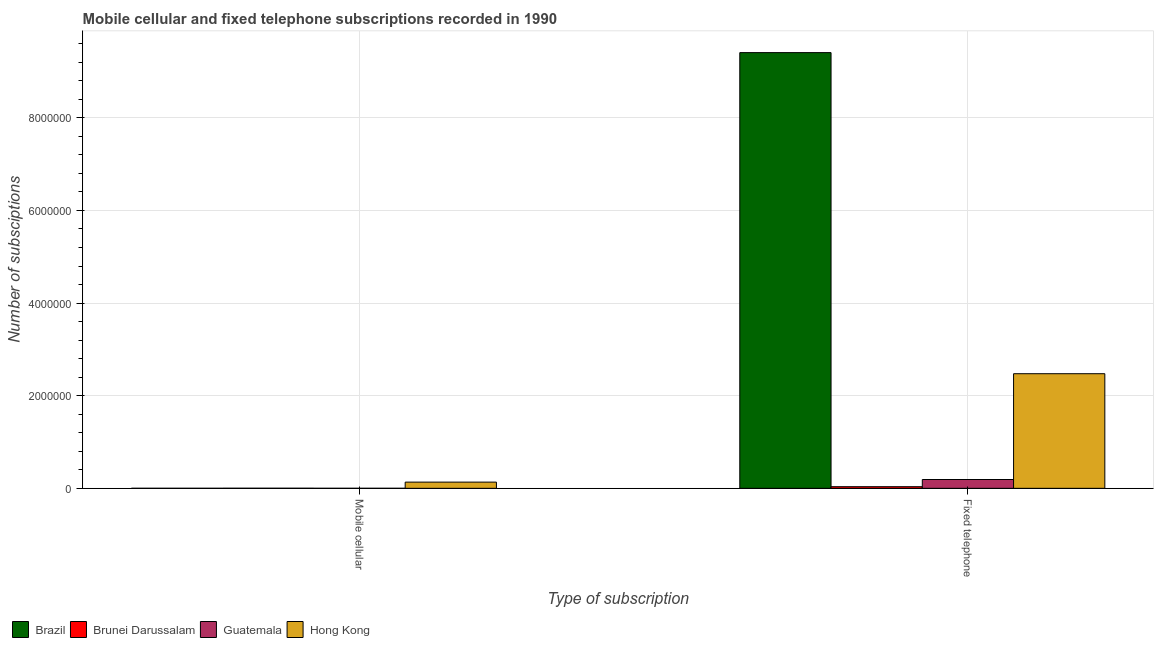How many different coloured bars are there?
Offer a terse response. 4. Are the number of bars per tick equal to the number of legend labels?
Your answer should be very brief. Yes. Are the number of bars on each tick of the X-axis equal?
Provide a succinct answer. Yes. How many bars are there on the 2nd tick from the right?
Your answer should be very brief. 4. What is the label of the 2nd group of bars from the left?
Provide a short and direct response. Fixed telephone. What is the number of fixed telephone subscriptions in Hong Kong?
Offer a very short reply. 2.47e+06. Across all countries, what is the maximum number of fixed telephone subscriptions?
Make the answer very short. 9.41e+06. Across all countries, what is the minimum number of fixed telephone subscriptions?
Offer a terse response. 3.50e+04. In which country was the number of mobile cellular subscriptions minimum?
Make the answer very short. Guatemala. What is the total number of fixed telephone subscriptions in the graph?
Your answer should be very brief. 1.21e+07. What is the difference between the number of mobile cellular subscriptions in Brunei Darussalam and that in Hong Kong?
Offer a terse response. -1.32e+05. What is the difference between the number of mobile cellular subscriptions in Brazil and the number of fixed telephone subscriptions in Guatemala?
Make the answer very short. -1.90e+05. What is the average number of mobile cellular subscriptions per country?
Your answer should be compact. 3.42e+04. What is the difference between the number of mobile cellular subscriptions and number of fixed telephone subscriptions in Guatemala?
Your answer should be very brief. -1.90e+05. In how many countries, is the number of mobile cellular subscriptions greater than 2800000 ?
Keep it short and to the point. 0. What is the ratio of the number of mobile cellular subscriptions in Hong Kong to that in Brazil?
Give a very brief answer. 200.77. What does the 2nd bar from the left in Mobile cellular represents?
Ensure brevity in your answer.  Brunei Darussalam. What does the 4th bar from the right in Mobile cellular represents?
Offer a terse response. Brazil. How many bars are there?
Provide a short and direct response. 8. Are all the bars in the graph horizontal?
Your response must be concise. No. What is the difference between two consecutive major ticks on the Y-axis?
Offer a terse response. 2.00e+06. Are the values on the major ticks of Y-axis written in scientific E-notation?
Offer a terse response. No. Does the graph contain any zero values?
Provide a short and direct response. No. Does the graph contain grids?
Ensure brevity in your answer.  Yes. How are the legend labels stacked?
Provide a short and direct response. Horizontal. What is the title of the graph?
Keep it short and to the point. Mobile cellular and fixed telephone subscriptions recorded in 1990. Does "Malawi" appear as one of the legend labels in the graph?
Provide a succinct answer. No. What is the label or title of the X-axis?
Give a very brief answer. Type of subscription. What is the label or title of the Y-axis?
Make the answer very short. Number of subsciptions. What is the Number of subsciptions of Brazil in Mobile cellular?
Provide a succinct answer. 667. What is the Number of subsciptions in Brunei Darussalam in Mobile cellular?
Your response must be concise. 1772. What is the Number of subsciptions in Guatemala in Mobile cellular?
Make the answer very short. 293. What is the Number of subsciptions of Hong Kong in Mobile cellular?
Your response must be concise. 1.34e+05. What is the Number of subsciptions in Brazil in Fixed telephone?
Your response must be concise. 9.41e+06. What is the Number of subsciptions in Brunei Darussalam in Fixed telephone?
Offer a terse response. 3.50e+04. What is the Number of subsciptions of Guatemala in Fixed telephone?
Offer a terse response. 1.90e+05. What is the Number of subsciptions of Hong Kong in Fixed telephone?
Your answer should be very brief. 2.47e+06. Across all Type of subscription, what is the maximum Number of subsciptions in Brazil?
Provide a short and direct response. 9.41e+06. Across all Type of subscription, what is the maximum Number of subsciptions of Brunei Darussalam?
Your answer should be compact. 3.50e+04. Across all Type of subscription, what is the maximum Number of subsciptions of Guatemala?
Your answer should be very brief. 1.90e+05. Across all Type of subscription, what is the maximum Number of subsciptions of Hong Kong?
Your response must be concise. 2.47e+06. Across all Type of subscription, what is the minimum Number of subsciptions in Brazil?
Keep it short and to the point. 667. Across all Type of subscription, what is the minimum Number of subsciptions of Brunei Darussalam?
Your answer should be very brief. 1772. Across all Type of subscription, what is the minimum Number of subsciptions in Guatemala?
Provide a short and direct response. 293. Across all Type of subscription, what is the minimum Number of subsciptions of Hong Kong?
Your answer should be compact. 1.34e+05. What is the total Number of subsciptions in Brazil in the graph?
Your response must be concise. 9.41e+06. What is the total Number of subsciptions in Brunei Darussalam in the graph?
Ensure brevity in your answer.  3.68e+04. What is the total Number of subsciptions of Guatemala in the graph?
Your answer should be very brief. 1.91e+05. What is the total Number of subsciptions in Hong Kong in the graph?
Provide a short and direct response. 2.61e+06. What is the difference between the Number of subsciptions in Brazil in Mobile cellular and that in Fixed telephone?
Provide a short and direct response. -9.41e+06. What is the difference between the Number of subsciptions of Brunei Darussalam in Mobile cellular and that in Fixed telephone?
Offer a terse response. -3.32e+04. What is the difference between the Number of subsciptions in Guatemala in Mobile cellular and that in Fixed telephone?
Provide a short and direct response. -1.90e+05. What is the difference between the Number of subsciptions in Hong Kong in Mobile cellular and that in Fixed telephone?
Give a very brief answer. -2.34e+06. What is the difference between the Number of subsciptions of Brazil in Mobile cellular and the Number of subsciptions of Brunei Darussalam in Fixed telephone?
Your answer should be compact. -3.43e+04. What is the difference between the Number of subsciptions in Brazil in Mobile cellular and the Number of subsciptions in Guatemala in Fixed telephone?
Ensure brevity in your answer.  -1.90e+05. What is the difference between the Number of subsciptions in Brazil in Mobile cellular and the Number of subsciptions in Hong Kong in Fixed telephone?
Provide a short and direct response. -2.47e+06. What is the difference between the Number of subsciptions of Brunei Darussalam in Mobile cellular and the Number of subsciptions of Guatemala in Fixed telephone?
Offer a terse response. -1.88e+05. What is the difference between the Number of subsciptions in Brunei Darussalam in Mobile cellular and the Number of subsciptions in Hong Kong in Fixed telephone?
Offer a very short reply. -2.47e+06. What is the difference between the Number of subsciptions in Guatemala in Mobile cellular and the Number of subsciptions in Hong Kong in Fixed telephone?
Keep it short and to the point. -2.47e+06. What is the average Number of subsciptions of Brazil per Type of subscription?
Give a very brief answer. 4.70e+06. What is the average Number of subsciptions in Brunei Darussalam per Type of subscription?
Give a very brief answer. 1.84e+04. What is the average Number of subsciptions in Guatemala per Type of subscription?
Offer a very short reply. 9.53e+04. What is the average Number of subsciptions of Hong Kong per Type of subscription?
Your response must be concise. 1.30e+06. What is the difference between the Number of subsciptions of Brazil and Number of subsciptions of Brunei Darussalam in Mobile cellular?
Give a very brief answer. -1105. What is the difference between the Number of subsciptions in Brazil and Number of subsciptions in Guatemala in Mobile cellular?
Offer a terse response. 374. What is the difference between the Number of subsciptions of Brazil and Number of subsciptions of Hong Kong in Mobile cellular?
Offer a terse response. -1.33e+05. What is the difference between the Number of subsciptions of Brunei Darussalam and Number of subsciptions of Guatemala in Mobile cellular?
Provide a succinct answer. 1479. What is the difference between the Number of subsciptions of Brunei Darussalam and Number of subsciptions of Hong Kong in Mobile cellular?
Your answer should be very brief. -1.32e+05. What is the difference between the Number of subsciptions in Guatemala and Number of subsciptions in Hong Kong in Mobile cellular?
Your answer should be compact. -1.34e+05. What is the difference between the Number of subsciptions in Brazil and Number of subsciptions in Brunei Darussalam in Fixed telephone?
Your answer should be very brief. 9.37e+06. What is the difference between the Number of subsciptions in Brazil and Number of subsciptions in Guatemala in Fixed telephone?
Your response must be concise. 9.22e+06. What is the difference between the Number of subsciptions in Brazil and Number of subsciptions in Hong Kong in Fixed telephone?
Provide a short and direct response. 6.93e+06. What is the difference between the Number of subsciptions of Brunei Darussalam and Number of subsciptions of Guatemala in Fixed telephone?
Your response must be concise. -1.55e+05. What is the difference between the Number of subsciptions of Brunei Darussalam and Number of subsciptions of Hong Kong in Fixed telephone?
Offer a very short reply. -2.44e+06. What is the difference between the Number of subsciptions in Guatemala and Number of subsciptions in Hong Kong in Fixed telephone?
Your answer should be compact. -2.28e+06. What is the ratio of the Number of subsciptions in Brunei Darussalam in Mobile cellular to that in Fixed telephone?
Your answer should be very brief. 0.05. What is the ratio of the Number of subsciptions in Guatemala in Mobile cellular to that in Fixed telephone?
Provide a short and direct response. 0. What is the ratio of the Number of subsciptions in Hong Kong in Mobile cellular to that in Fixed telephone?
Offer a terse response. 0.05. What is the difference between the highest and the second highest Number of subsciptions of Brazil?
Offer a terse response. 9.41e+06. What is the difference between the highest and the second highest Number of subsciptions of Brunei Darussalam?
Ensure brevity in your answer.  3.32e+04. What is the difference between the highest and the second highest Number of subsciptions of Guatemala?
Ensure brevity in your answer.  1.90e+05. What is the difference between the highest and the second highest Number of subsciptions of Hong Kong?
Provide a succinct answer. 2.34e+06. What is the difference between the highest and the lowest Number of subsciptions in Brazil?
Offer a terse response. 9.41e+06. What is the difference between the highest and the lowest Number of subsciptions of Brunei Darussalam?
Your response must be concise. 3.32e+04. What is the difference between the highest and the lowest Number of subsciptions of Guatemala?
Keep it short and to the point. 1.90e+05. What is the difference between the highest and the lowest Number of subsciptions of Hong Kong?
Offer a very short reply. 2.34e+06. 